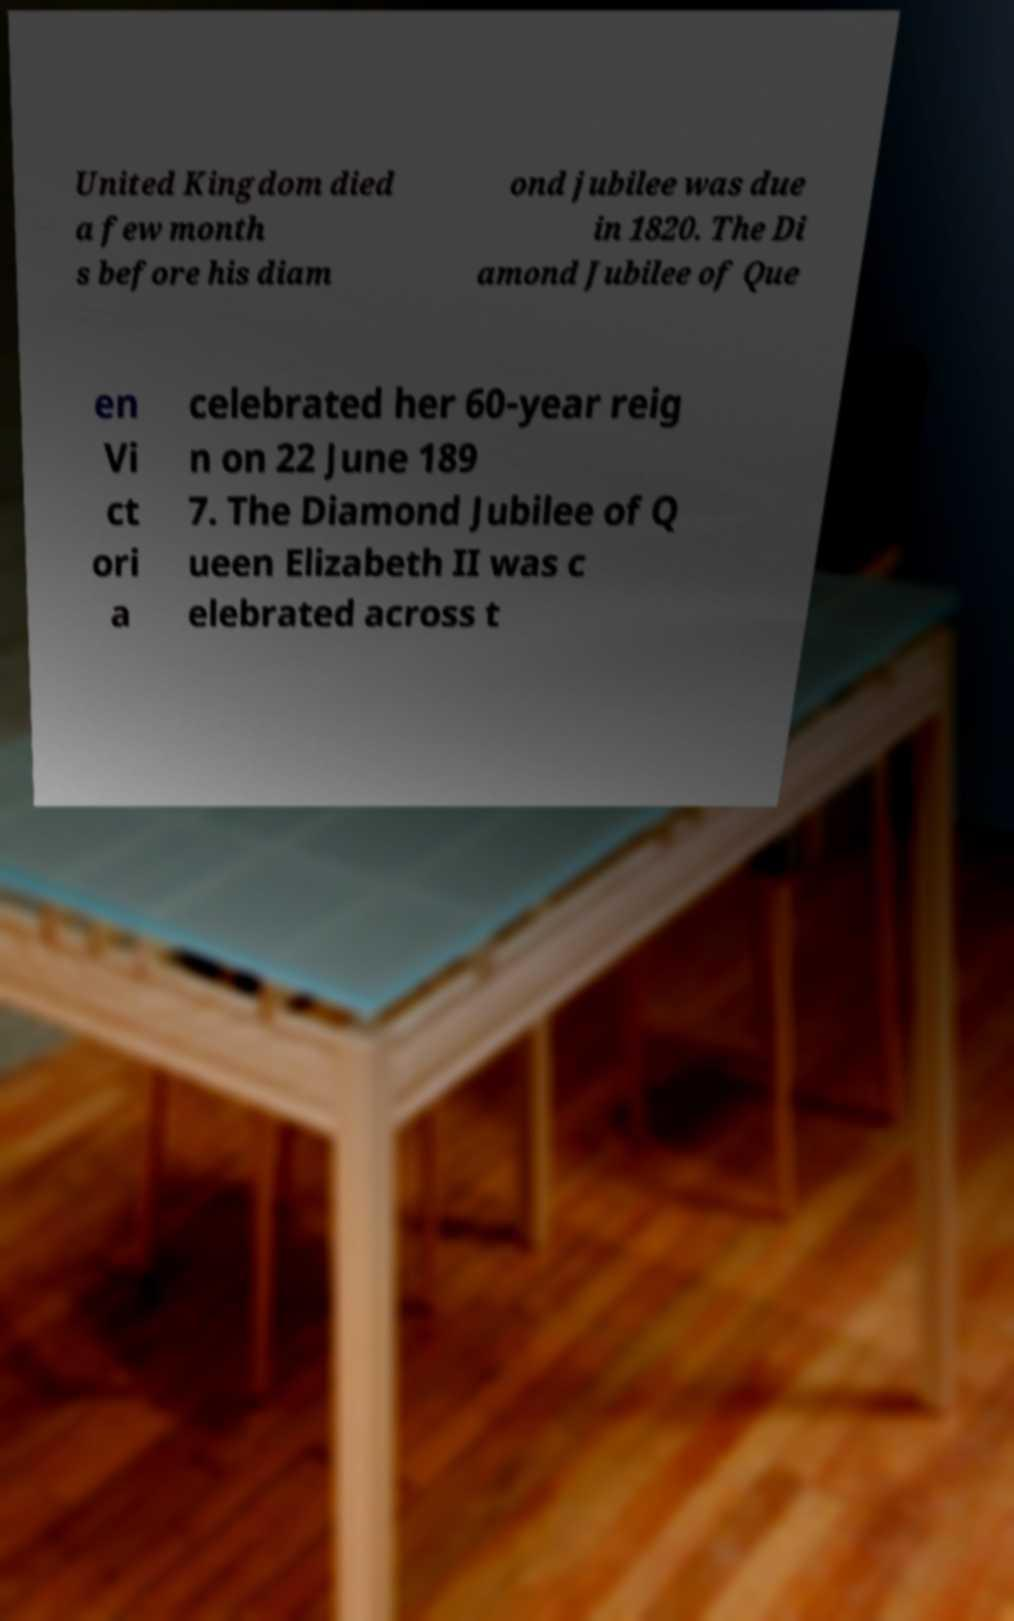There's text embedded in this image that I need extracted. Can you transcribe it verbatim? United Kingdom died a few month s before his diam ond jubilee was due in 1820. The Di amond Jubilee of Que en Vi ct ori a celebrated her 60-year reig n on 22 June 189 7. The Diamond Jubilee of Q ueen Elizabeth II was c elebrated across t 